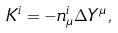<formula> <loc_0><loc_0><loc_500><loc_500>K ^ { i } = - n ^ { i } _ { \mu } \Delta Y ^ { \mu } \, ,</formula> 